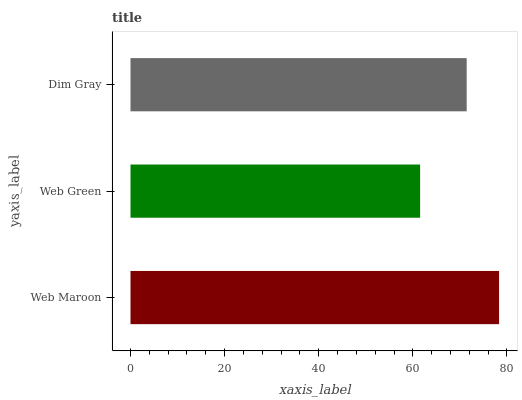Is Web Green the minimum?
Answer yes or no. Yes. Is Web Maroon the maximum?
Answer yes or no. Yes. Is Dim Gray the minimum?
Answer yes or no. No. Is Dim Gray the maximum?
Answer yes or no. No. Is Dim Gray greater than Web Green?
Answer yes or no. Yes. Is Web Green less than Dim Gray?
Answer yes or no. Yes. Is Web Green greater than Dim Gray?
Answer yes or no. No. Is Dim Gray less than Web Green?
Answer yes or no. No. Is Dim Gray the high median?
Answer yes or no. Yes. Is Dim Gray the low median?
Answer yes or no. Yes. Is Web Green the high median?
Answer yes or no. No. Is Web Maroon the low median?
Answer yes or no. No. 